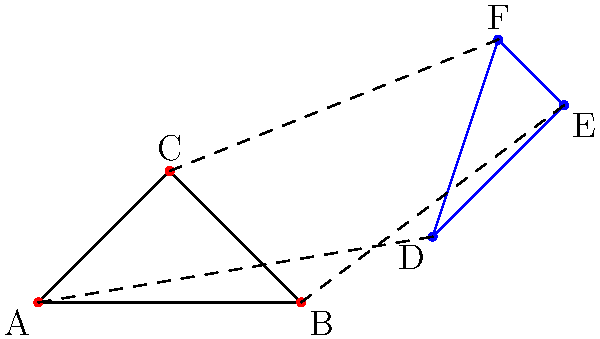In non-Euclidean geometry, a transformation that maps triangle ABC to triangle DEF can be likened to a chord progression in U2's "With or Without You". If the transformation represents the shift from the song's verse to chorus, which non-Euclidean property is most analogous to the emotional intensity change in the progression? To answer this question, let's break down the analogy step-by-step:

1. In non-Euclidean geometry, transformations can distort shapes in ways not possible in Euclidean geometry. This is similar to how chord progressions in music can create emotional shifts.

2. The transformation from triangle ABC to DEF involves:
   a) Translation: The overall position of the triangle has moved.
   b) Dilation: The size of the triangle has increased.
   c) Rotation: The orientation of the triangle has changed.

3. In U2's "With or Without You", the chord progression from verse to chorus creates a sense of emotional buildup and release. This is achieved through:
   a) Harmonic tension: Moving from simpler to more complex chords.
   b) Dynamic increase: The volume and intensity of the instruments grow.
   c) Melodic ascent: The vocal line tends to rise in pitch.

4. The non-Euclidean property that best captures this emotional intensity change is the concept of "hyperbolic expansion". In hyperbolic geometry, as objects move away from a central point, they appear to grow exponentially larger.

5. This hyperbolic expansion is analogous to the emotional intensity in the song because:
   a) It represents a rapid growth or change, similar to the sudden emotional impact of the chorus.
   b) It involves a shift in perspective, much like how the chorus provides a new viewpoint on the song's themes.
   c) The expansion is non-linear, reflecting the complex, multidimensional nature of emotional experiences in music.

Therefore, the non-Euclidean property most analogous to the emotional intensity change in the chord progression is hyperbolic expansion.
Answer: Hyperbolic expansion 